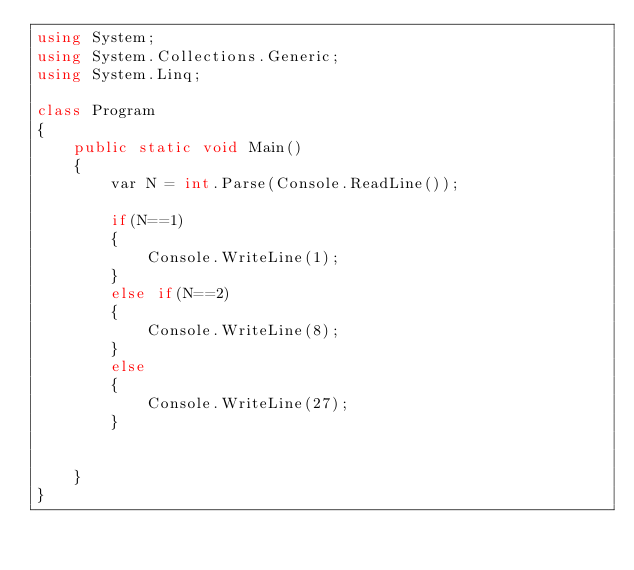<code> <loc_0><loc_0><loc_500><loc_500><_C#_>using System;
using System.Collections.Generic;
using System.Linq;

class Program
{
    public static void Main()
    {
        var N = int.Parse(Console.ReadLine());
       
        if(N==1)
        {
            Console.WriteLine(1);
        }
        else if(N==2)
        {
            Console.WriteLine(8);
        }
        else
        {
            Console.WriteLine(27);
        }

        
    }
}</code> 